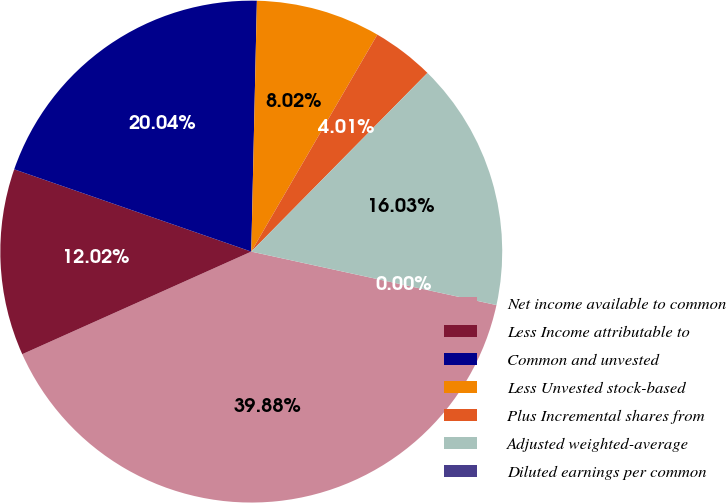Convert chart. <chart><loc_0><loc_0><loc_500><loc_500><pie_chart><fcel>Net income available to common<fcel>Less Income attributable to<fcel>Common and unvested<fcel>Less Unvested stock-based<fcel>Plus Incremental shares from<fcel>Adjusted weighted-average<fcel>Diluted earnings per common<nl><fcel>39.88%<fcel>12.02%<fcel>20.04%<fcel>8.02%<fcel>4.01%<fcel>16.03%<fcel>0.0%<nl></chart> 